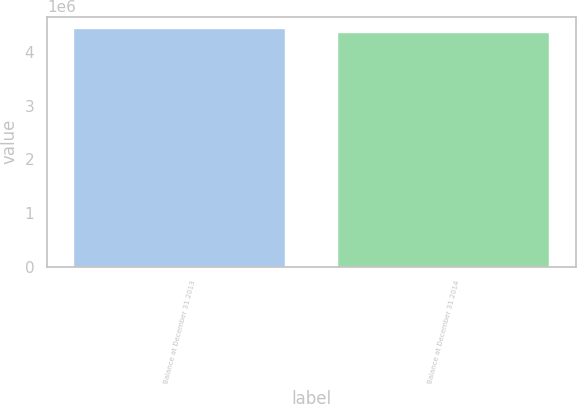<chart> <loc_0><loc_0><loc_500><loc_500><bar_chart><fcel>Balance at December 31 2013<fcel>Balance at December 31 2014<nl><fcel>4.43663e+06<fcel>4.34699e+06<nl></chart> 